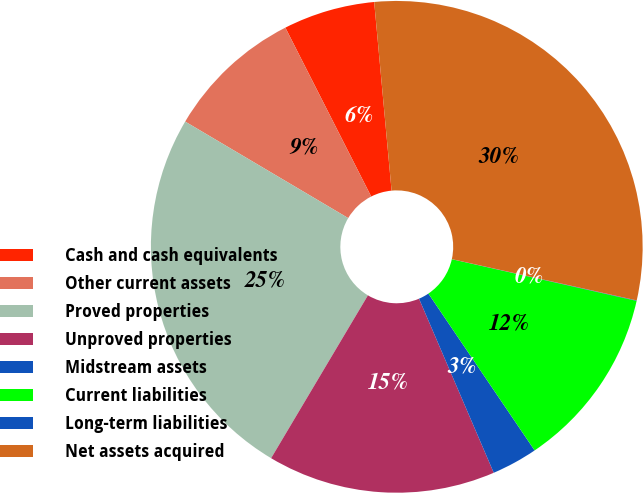Convert chart. <chart><loc_0><loc_0><loc_500><loc_500><pie_chart><fcel>Cash and cash equivalents<fcel>Other current assets<fcel>Proved properties<fcel>Unproved properties<fcel>Midstream assets<fcel>Current liabilities<fcel>Long-term liabilities<fcel>Net assets acquired<nl><fcel>6.02%<fcel>9.01%<fcel>24.97%<fcel>14.99%<fcel>3.02%<fcel>12.0%<fcel>0.03%<fcel>29.96%<nl></chart> 